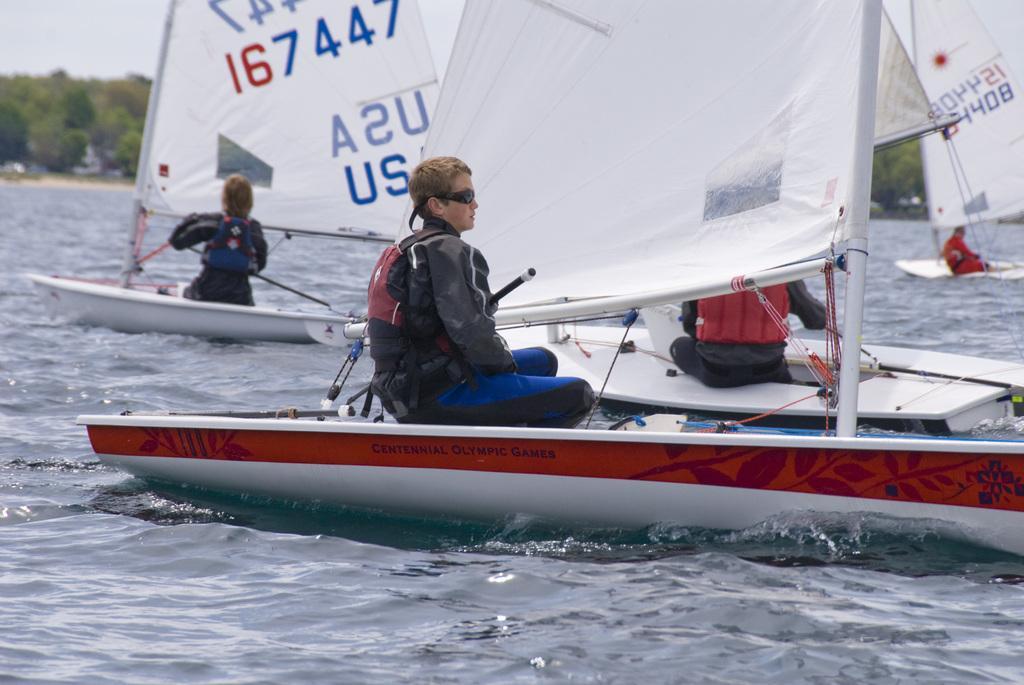In one or two sentences, can you explain what this image depicts? In this image we can see persons in boats sailing on the water. In the background we can see trees and sky. 